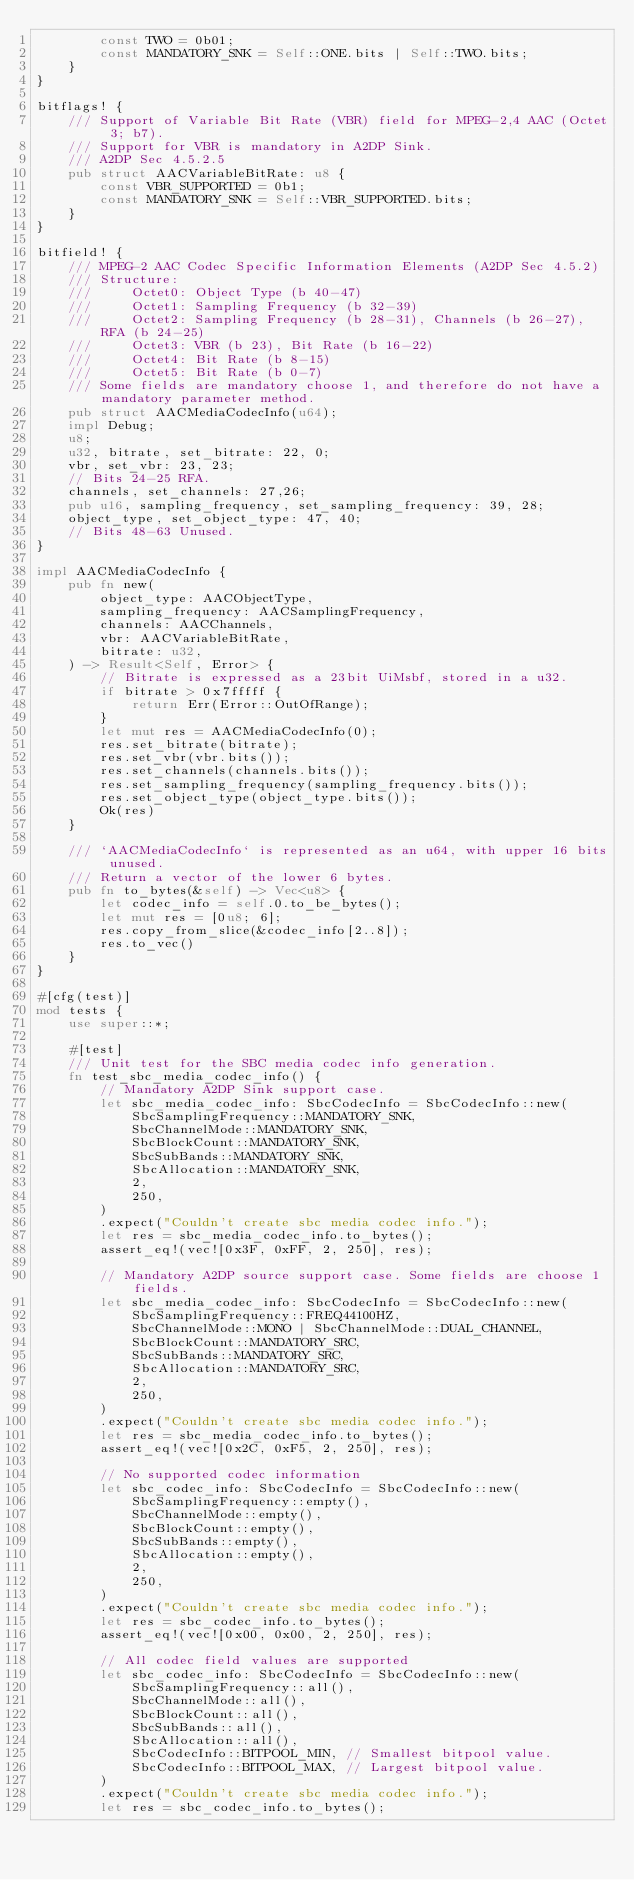Convert code to text. <code><loc_0><loc_0><loc_500><loc_500><_Rust_>        const TWO = 0b01;
        const MANDATORY_SNK = Self::ONE.bits | Self::TWO.bits;
    }
}

bitflags! {
    /// Support of Variable Bit Rate (VBR) field for MPEG-2,4 AAC (Octet 3; b7).
    /// Support for VBR is mandatory in A2DP Sink.
    /// A2DP Sec 4.5.2.5
    pub struct AACVariableBitRate: u8 {
        const VBR_SUPPORTED = 0b1;
        const MANDATORY_SNK = Self::VBR_SUPPORTED.bits;
    }
}

bitfield! {
    /// MPEG-2 AAC Codec Specific Information Elements (A2DP Sec 4.5.2)
    /// Structure:
    ///     Octet0: Object Type (b 40-47)
    ///     Octet1: Sampling Frequency (b 32-39)
    ///     Octet2: Sampling Frequency (b 28-31), Channels (b 26-27), RFA (b 24-25)
    ///     Octet3: VBR (b 23), Bit Rate (b 16-22)
    ///     Octet4: Bit Rate (b 8-15)
    ///     Octet5: Bit Rate (b 0-7)
    /// Some fields are mandatory choose 1, and therefore do not have a mandatory parameter method.
    pub struct AACMediaCodecInfo(u64);
    impl Debug;
    u8;
    u32, bitrate, set_bitrate: 22, 0;
    vbr, set_vbr: 23, 23;
    // Bits 24-25 RFA.
    channels, set_channels: 27,26;
    pub u16, sampling_frequency, set_sampling_frequency: 39, 28;
    object_type, set_object_type: 47, 40;
    // Bits 48-63 Unused.
}

impl AACMediaCodecInfo {
    pub fn new(
        object_type: AACObjectType,
        sampling_frequency: AACSamplingFrequency,
        channels: AACChannels,
        vbr: AACVariableBitRate,
        bitrate: u32,
    ) -> Result<Self, Error> {
        // Bitrate is expressed as a 23bit UiMsbf, stored in a u32.
        if bitrate > 0x7fffff {
            return Err(Error::OutOfRange);
        }
        let mut res = AACMediaCodecInfo(0);
        res.set_bitrate(bitrate);
        res.set_vbr(vbr.bits());
        res.set_channels(channels.bits());
        res.set_sampling_frequency(sampling_frequency.bits());
        res.set_object_type(object_type.bits());
        Ok(res)
    }

    /// `AACMediaCodecInfo` is represented as an u64, with upper 16 bits unused.
    /// Return a vector of the lower 6 bytes.
    pub fn to_bytes(&self) -> Vec<u8> {
        let codec_info = self.0.to_be_bytes();
        let mut res = [0u8; 6];
        res.copy_from_slice(&codec_info[2..8]);
        res.to_vec()
    }
}

#[cfg(test)]
mod tests {
    use super::*;

    #[test]
    /// Unit test for the SBC media codec info generation.
    fn test_sbc_media_codec_info() {
        // Mandatory A2DP Sink support case.
        let sbc_media_codec_info: SbcCodecInfo = SbcCodecInfo::new(
            SbcSamplingFrequency::MANDATORY_SNK,
            SbcChannelMode::MANDATORY_SNK,
            SbcBlockCount::MANDATORY_SNK,
            SbcSubBands::MANDATORY_SNK,
            SbcAllocation::MANDATORY_SNK,
            2,
            250,
        )
        .expect("Couldn't create sbc media codec info.");
        let res = sbc_media_codec_info.to_bytes();
        assert_eq!(vec![0x3F, 0xFF, 2, 250], res);

        // Mandatory A2DP source support case. Some fields are choose 1 fields.
        let sbc_media_codec_info: SbcCodecInfo = SbcCodecInfo::new(
            SbcSamplingFrequency::FREQ44100HZ,
            SbcChannelMode::MONO | SbcChannelMode::DUAL_CHANNEL,
            SbcBlockCount::MANDATORY_SRC,
            SbcSubBands::MANDATORY_SRC,
            SbcAllocation::MANDATORY_SRC,
            2,
            250,
        )
        .expect("Couldn't create sbc media codec info.");
        let res = sbc_media_codec_info.to_bytes();
        assert_eq!(vec![0x2C, 0xF5, 2, 250], res);

        // No supported codec information
        let sbc_codec_info: SbcCodecInfo = SbcCodecInfo::new(
            SbcSamplingFrequency::empty(),
            SbcChannelMode::empty(),
            SbcBlockCount::empty(),
            SbcSubBands::empty(),
            SbcAllocation::empty(),
            2,
            250,
        )
        .expect("Couldn't create sbc media codec info.");
        let res = sbc_codec_info.to_bytes();
        assert_eq!(vec![0x00, 0x00, 2, 250], res);

        // All codec field values are supported
        let sbc_codec_info: SbcCodecInfo = SbcCodecInfo::new(
            SbcSamplingFrequency::all(),
            SbcChannelMode::all(),
            SbcBlockCount::all(),
            SbcSubBands::all(),
            SbcAllocation::all(),
            SbcCodecInfo::BITPOOL_MIN, // Smallest bitpool value.
            SbcCodecInfo::BITPOOL_MAX, // Largest bitpool value.
        )
        .expect("Couldn't create sbc media codec info.");
        let res = sbc_codec_info.to_bytes();</code> 